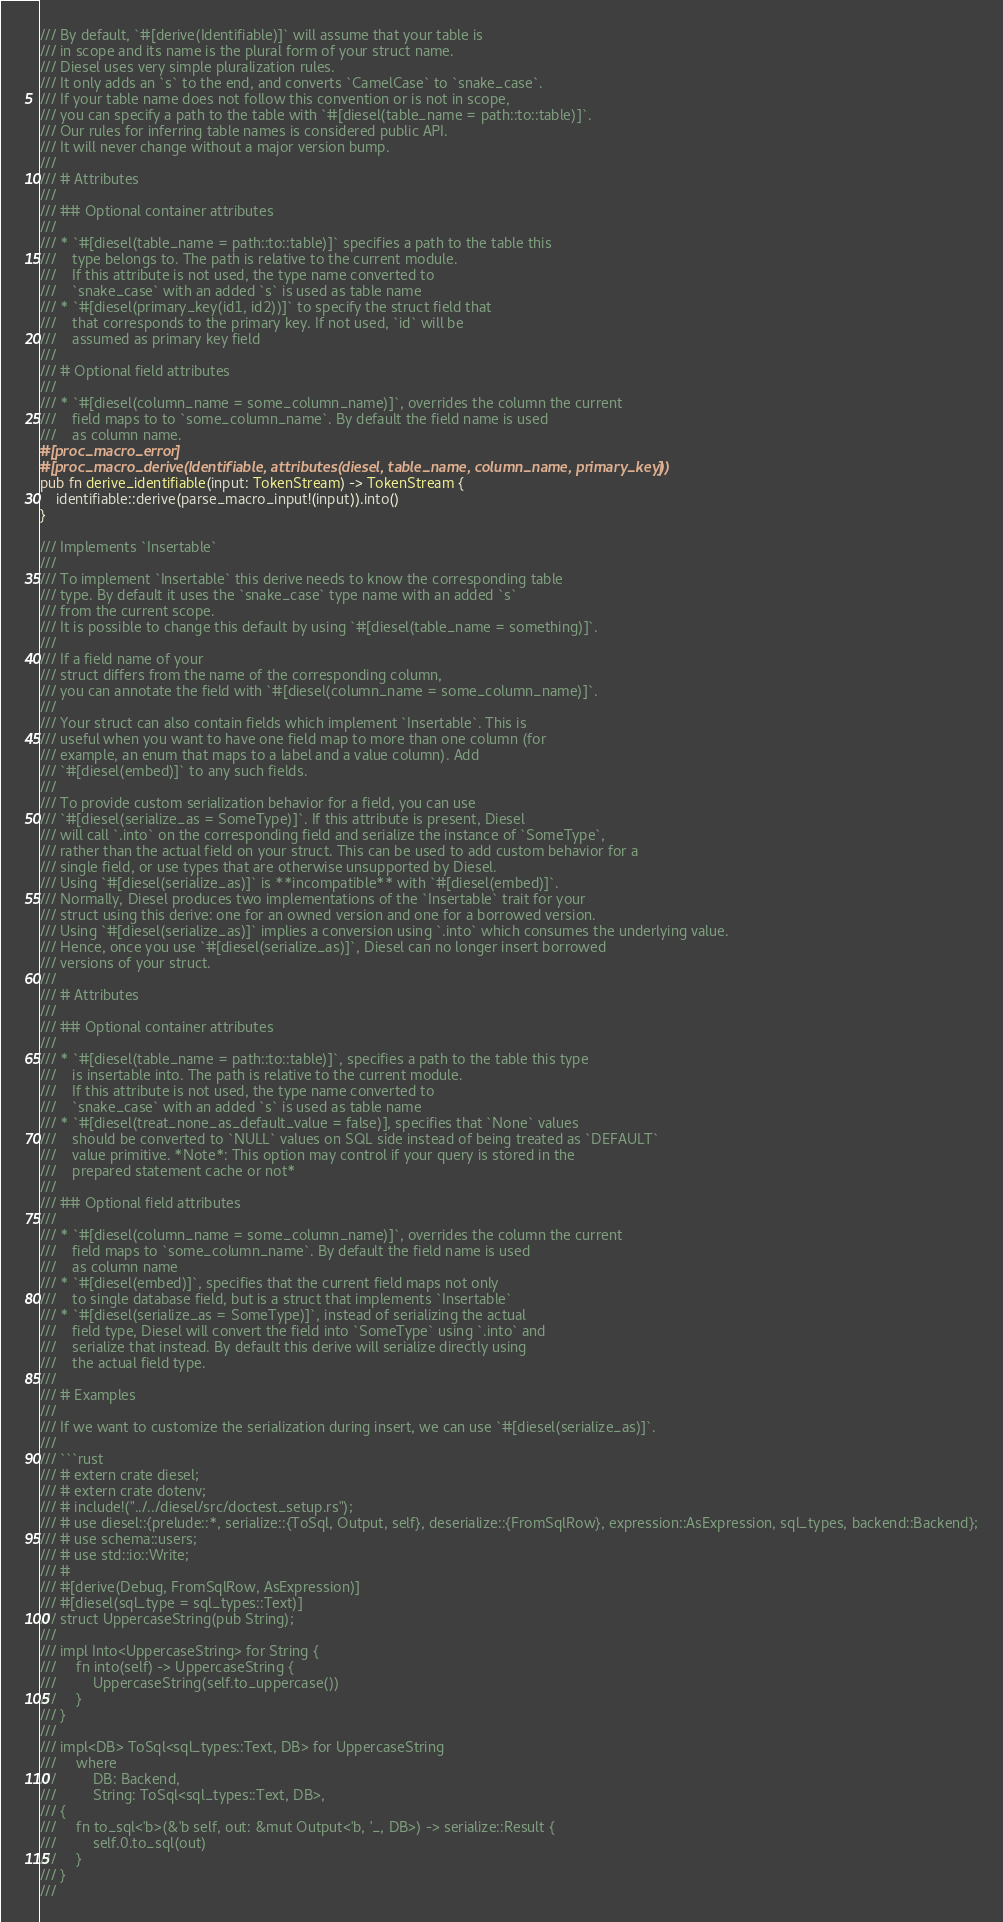<code> <loc_0><loc_0><loc_500><loc_500><_Rust_>/// By default, `#[derive(Identifiable)]` will assume that your table is
/// in scope and its name is the plural form of your struct name.
/// Diesel uses very simple pluralization rules.
/// It only adds an `s` to the end, and converts `CamelCase` to `snake_case`.
/// If your table name does not follow this convention or is not in scope,
/// you can specify a path to the table with `#[diesel(table_name = path::to::table)]`.
/// Our rules for inferring table names is considered public API.
/// It will never change without a major version bump.
///
/// # Attributes
///
/// ## Optional container attributes
///
/// * `#[diesel(table_name = path::to::table)]` specifies a path to the table this
///    type belongs to. The path is relative to the current module.
///    If this attribute is not used, the type name converted to
///    `snake_case` with an added `s` is used as table name
/// * `#[diesel(primary_key(id1, id2))]` to specify the struct field that
///    that corresponds to the primary key. If not used, `id` will be
///    assumed as primary key field
///
/// # Optional field attributes
///
/// * `#[diesel(column_name = some_column_name)]`, overrides the column the current
///    field maps to to `some_column_name`. By default the field name is used
///    as column name.
#[proc_macro_error]
#[proc_macro_derive(Identifiable, attributes(diesel, table_name, column_name, primary_key))]
pub fn derive_identifiable(input: TokenStream) -> TokenStream {
    identifiable::derive(parse_macro_input!(input)).into()
}

/// Implements `Insertable`
///
/// To implement `Insertable` this derive needs to know the corresponding table
/// type. By default it uses the `snake_case` type name with an added `s`
/// from the current scope.
/// It is possible to change this default by using `#[diesel(table_name = something)]`.
///
/// If a field name of your
/// struct differs from the name of the corresponding column,
/// you can annotate the field with `#[diesel(column_name = some_column_name)]`.
///
/// Your struct can also contain fields which implement `Insertable`. This is
/// useful when you want to have one field map to more than one column (for
/// example, an enum that maps to a label and a value column). Add
/// `#[diesel(embed)]` to any such fields.
///
/// To provide custom serialization behavior for a field, you can use
/// `#[diesel(serialize_as = SomeType)]`. If this attribute is present, Diesel
/// will call `.into` on the corresponding field and serialize the instance of `SomeType`,
/// rather than the actual field on your struct. This can be used to add custom behavior for a
/// single field, or use types that are otherwise unsupported by Diesel.
/// Using `#[diesel(serialize_as)]` is **incompatible** with `#[diesel(embed)]`.
/// Normally, Diesel produces two implementations of the `Insertable` trait for your
/// struct using this derive: one for an owned version and one for a borrowed version.
/// Using `#[diesel(serialize_as)]` implies a conversion using `.into` which consumes the underlying value.
/// Hence, once you use `#[diesel(serialize_as)]`, Diesel can no longer insert borrowed
/// versions of your struct.
///
/// # Attributes
///
/// ## Optional container attributes
///
/// * `#[diesel(table_name = path::to::table)]`, specifies a path to the table this type
///    is insertable into. The path is relative to the current module.
///    If this attribute is not used, the type name converted to
///    `snake_case` with an added `s` is used as table name
/// * `#[diesel(treat_none_as_default_value = false)], specifies that `None` values
///    should be converted to `NULL` values on SQL side instead of being treated as `DEFAULT`
///    value primitive. *Note*: This option may control if your query is stored in the
///    prepared statement cache or not*
///
/// ## Optional field attributes
///
/// * `#[diesel(column_name = some_column_name)]`, overrides the column the current
///    field maps to `some_column_name`. By default the field name is used
///    as column name
/// * `#[diesel(embed)]`, specifies that the current field maps not only
///    to single database field, but is a struct that implements `Insertable`
/// * `#[diesel(serialize_as = SomeType)]`, instead of serializing the actual
///    field type, Diesel will convert the field into `SomeType` using `.into` and
///    serialize that instead. By default this derive will serialize directly using
///    the actual field type.
///
/// # Examples
///
/// If we want to customize the serialization during insert, we can use `#[diesel(serialize_as)]`.
///
/// ```rust
/// # extern crate diesel;
/// # extern crate dotenv;
/// # include!("../../diesel/src/doctest_setup.rs");
/// # use diesel::{prelude::*, serialize::{ToSql, Output, self}, deserialize::{FromSqlRow}, expression::AsExpression, sql_types, backend::Backend};
/// # use schema::users;
/// # use std::io::Write;
/// #
/// #[derive(Debug, FromSqlRow, AsExpression)]
/// #[diesel(sql_type = sql_types::Text)]
/// struct UppercaseString(pub String);
///
/// impl Into<UppercaseString> for String {
///     fn into(self) -> UppercaseString {
///         UppercaseString(self.to_uppercase())
///     }
/// }
///
/// impl<DB> ToSql<sql_types::Text, DB> for UppercaseString
///     where
///         DB: Backend,
///         String: ToSql<sql_types::Text, DB>,
/// {
///     fn to_sql<'b>(&'b self, out: &mut Output<'b, '_, DB>) -> serialize::Result {
///         self.0.to_sql(out)
///     }
/// }
///</code> 